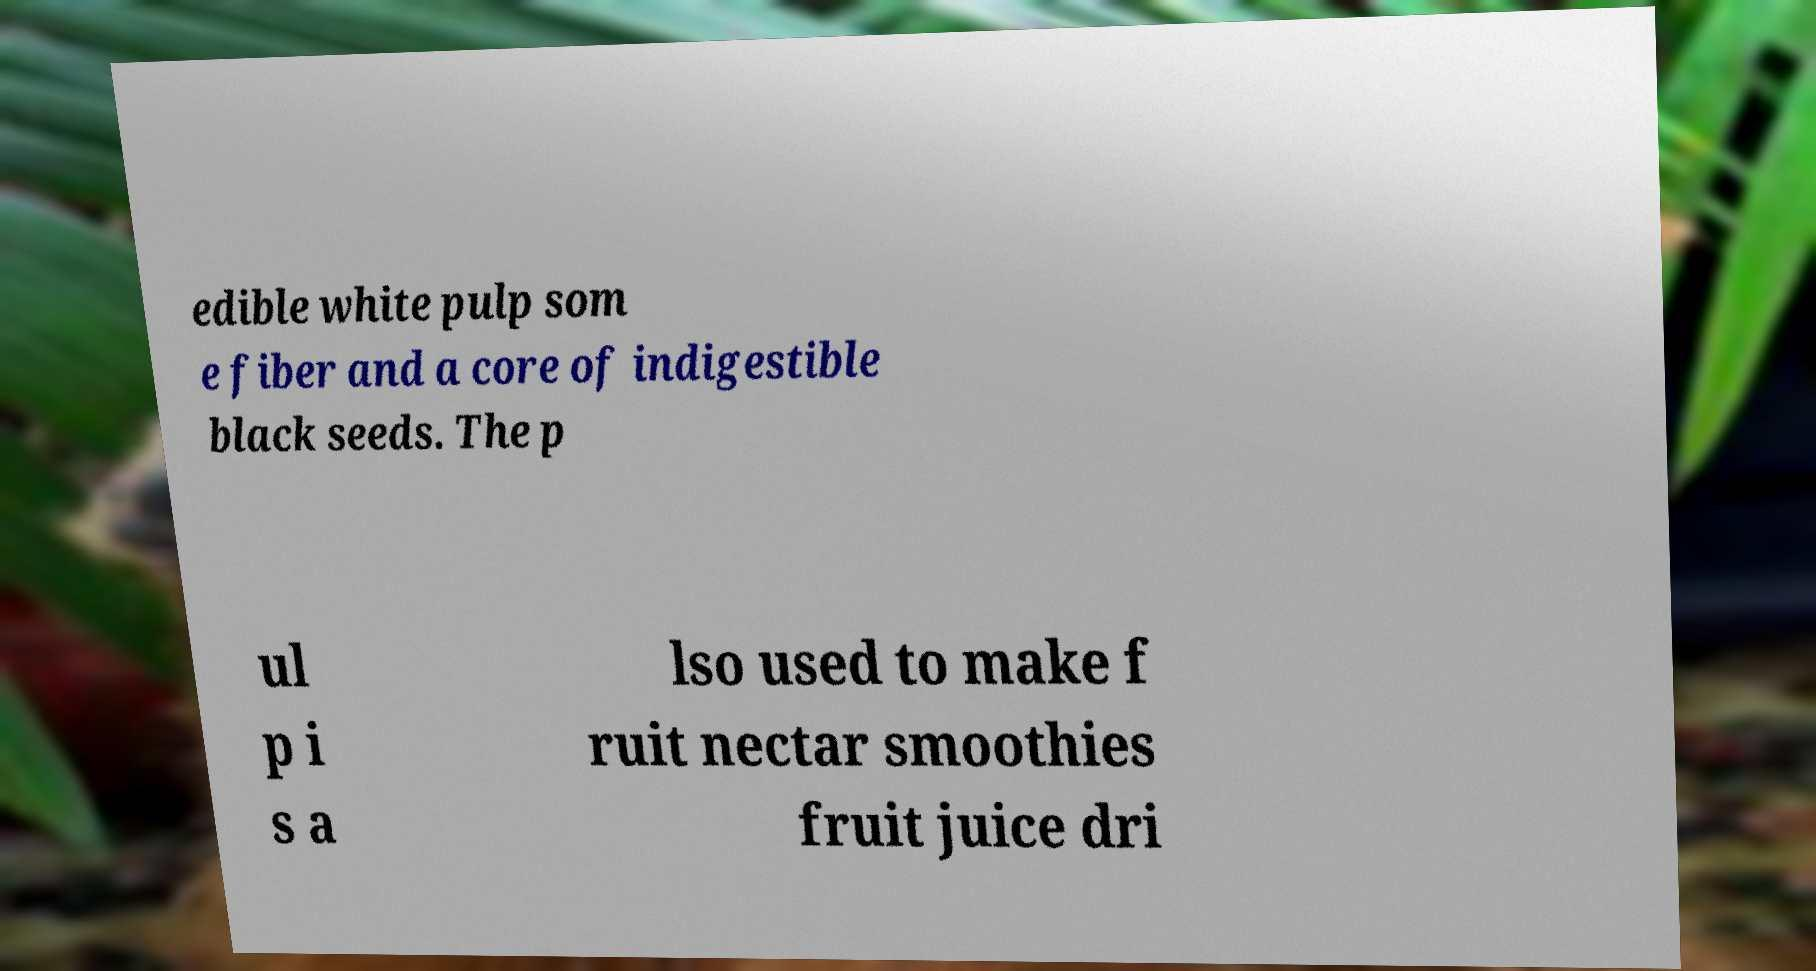For documentation purposes, I need the text within this image transcribed. Could you provide that? edible white pulp som e fiber and a core of indigestible black seeds. The p ul p i s a lso used to make f ruit nectar smoothies fruit juice dri 